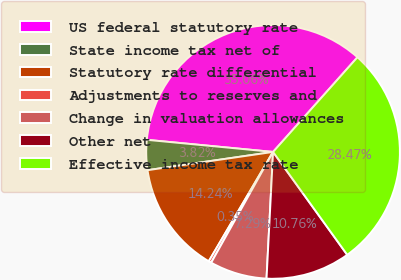Convert chart. <chart><loc_0><loc_0><loc_500><loc_500><pie_chart><fcel>US federal statutory rate<fcel>State income tax net of<fcel>Statutory rate differential<fcel>Adjustments to reserves and<fcel>Change in valuation allowances<fcel>Other net<fcel>Effective income tax rate<nl><fcel>35.06%<fcel>3.82%<fcel>14.24%<fcel>0.35%<fcel>7.29%<fcel>10.76%<fcel>28.47%<nl></chart> 